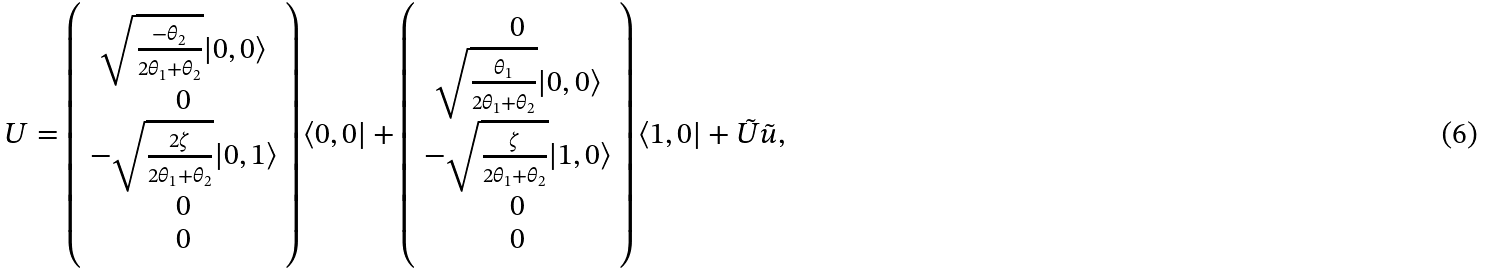<formula> <loc_0><loc_0><loc_500><loc_500>U = \left ( \begin{array} { c } \sqrt { \frac { - \theta _ { 2 } } { 2 \theta _ { 1 } + \theta _ { 2 } } } | 0 , 0 \rangle \\ 0 \\ - \sqrt { \frac { 2 \zeta } { 2 \theta _ { 1 } + \theta _ { 2 } } } | 0 , 1 \rangle \\ 0 \\ 0 \end{array} \right ) \langle 0 , 0 | + \left ( \begin{array} { c } 0 \\ \sqrt { \frac { \theta _ { 1 } } { 2 \theta _ { 1 } + \theta _ { 2 } } } | 0 , 0 \rangle \\ - \sqrt { \frac { \zeta } { 2 \theta _ { 1 } + \theta _ { 2 } } } | 1 , 0 \rangle \\ 0 \\ 0 \end{array} \right ) \langle 1 , 0 | + \tilde { U } \tilde { u } ,</formula> 